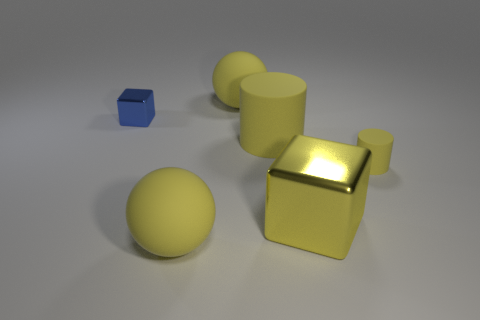How many large objects are the same material as the small blue thing?
Provide a short and direct response. 1. What number of objects are either yellow metallic cubes or metal objects that are in front of the tiny metallic thing?
Offer a terse response. 1. What color is the tiny object to the right of the large yellow sphere that is in front of the big yellow sphere that is behind the small yellow rubber cylinder?
Offer a terse response. Yellow. What is the size of the metal cube behind the tiny matte cylinder?
Provide a succinct answer. Small. How many big objects are yellow rubber spheres or metallic cubes?
Offer a very short reply. 3. What color is the rubber thing that is left of the large yellow matte cylinder and behind the small rubber object?
Offer a very short reply. Yellow. Is there a small cyan metallic object that has the same shape as the tiny yellow object?
Offer a terse response. No. What is the material of the big yellow cylinder?
Provide a succinct answer. Rubber. Are there any matte objects behind the small cylinder?
Offer a very short reply. Yes. Do the blue shiny thing and the big yellow shiny thing have the same shape?
Ensure brevity in your answer.  Yes. 